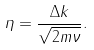<formula> <loc_0><loc_0><loc_500><loc_500>\eta = \frac { \Delta k } { \sqrt { 2 m \nu } } .</formula> 